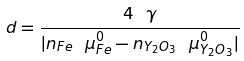<formula> <loc_0><loc_0><loc_500><loc_500>d = \frac { 4 \ \gamma } { | n _ { F e } \ \mu _ { F e } ^ { 0 } - n _ { Y _ { 2 } O _ { 3 } } \ \mu _ { Y _ { 2 } O _ { 3 } } ^ { 0 } | }</formula> 